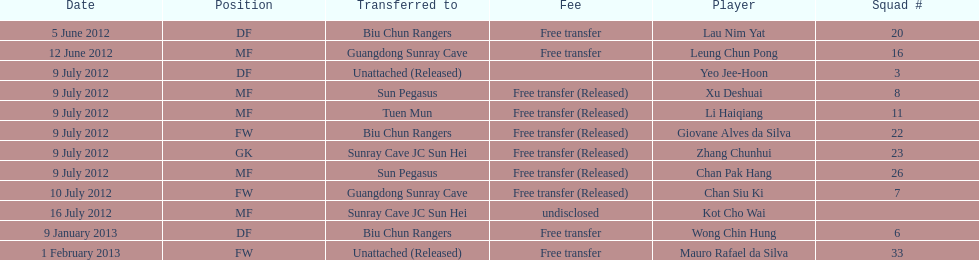How many total players were transferred to sun pegasus? 2. 